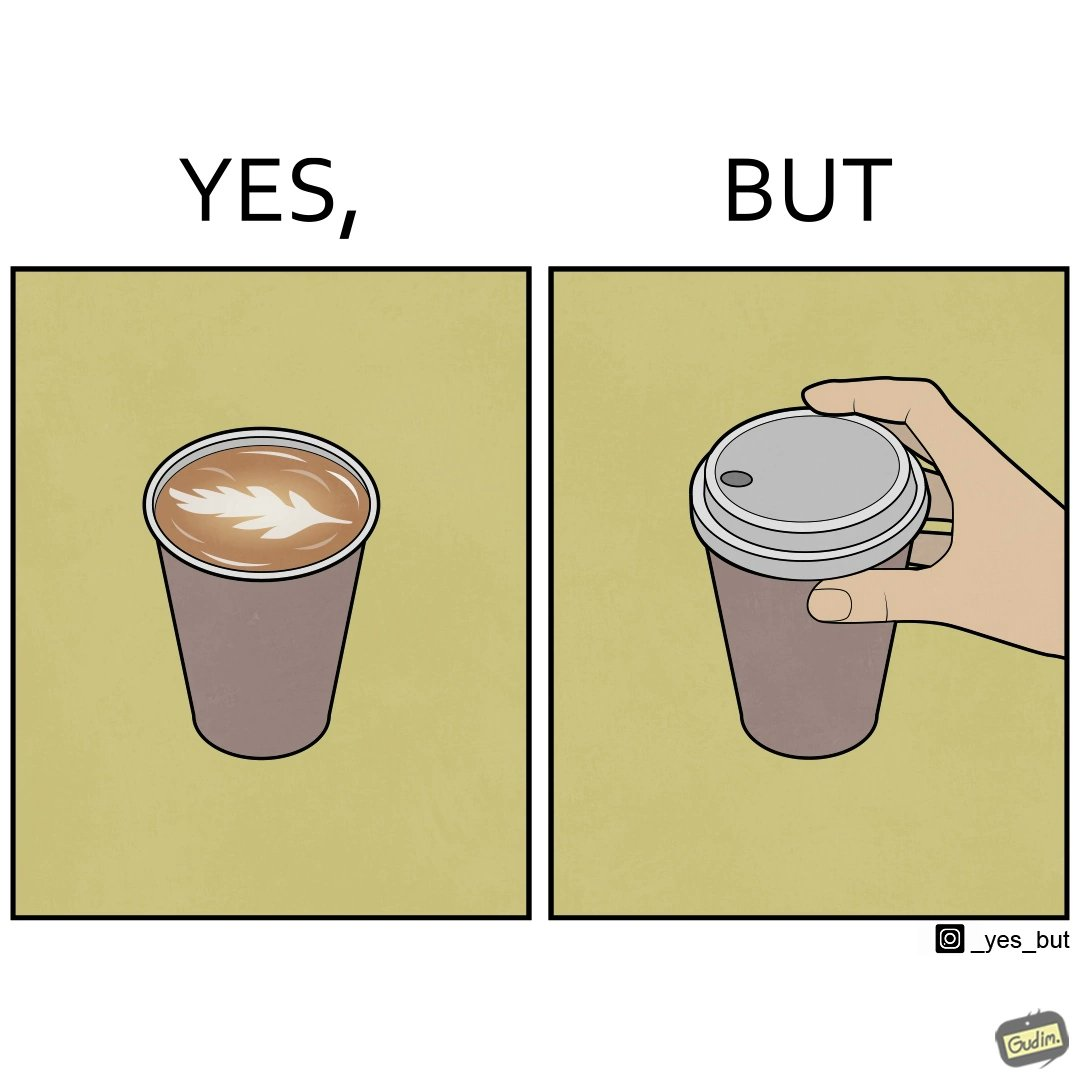Is there satirical content in this image? Yes, this image is satirical. 